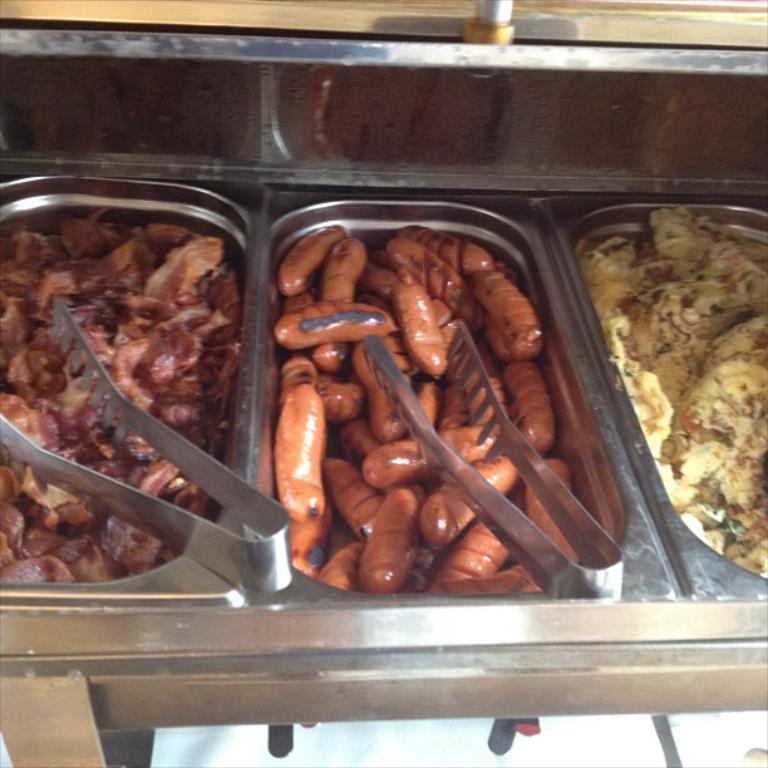Describe this image in one or two sentences. In this image there are food items in a food containers and there are tongs. 